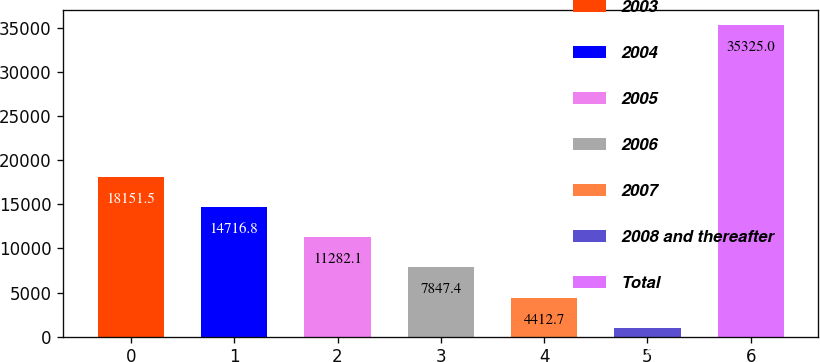Convert chart to OTSL. <chart><loc_0><loc_0><loc_500><loc_500><bar_chart><fcel>2003<fcel>2004<fcel>2005<fcel>2006<fcel>2007<fcel>2008 and thereafter<fcel>Total<nl><fcel>18151.5<fcel>14716.8<fcel>11282.1<fcel>7847.4<fcel>4412.7<fcel>978<fcel>35325<nl></chart> 